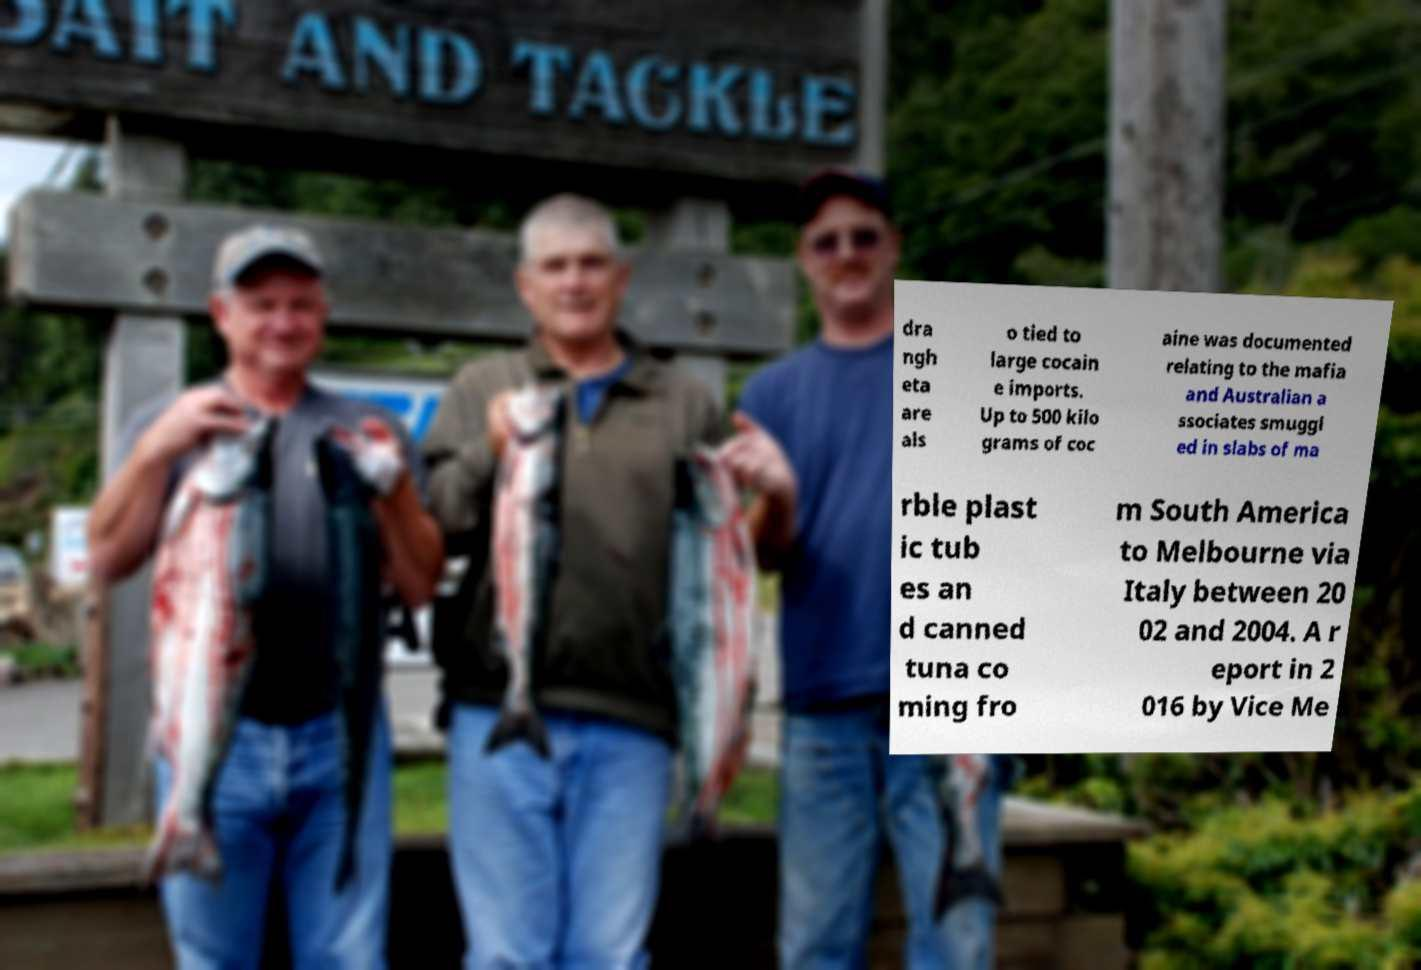Please read and relay the text visible in this image. What does it say? dra ngh eta are als o tied to large cocain e imports. Up to 500 kilo grams of coc aine was documented relating to the mafia and Australian a ssociates smuggl ed in slabs of ma rble plast ic tub es an d canned tuna co ming fro m South America to Melbourne via Italy between 20 02 and 2004. A r eport in 2 016 by Vice Me 